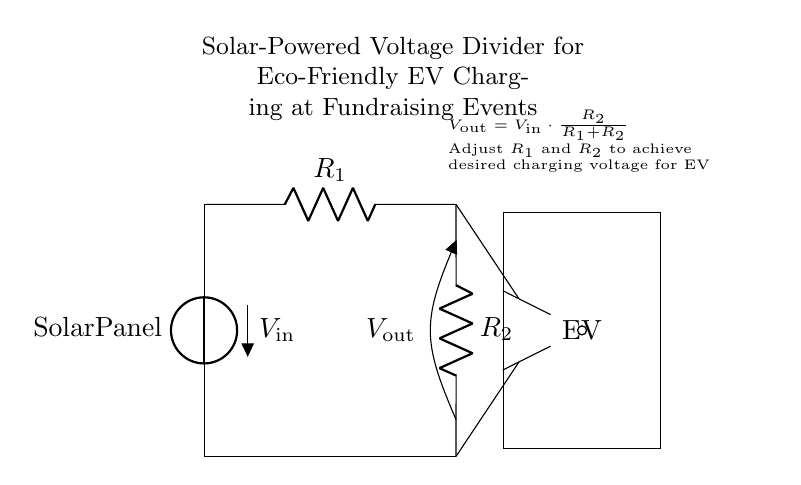What is the input voltage source in the circuit? The input voltage source is labeled as the solar panel, which provides the initial voltage for the voltage divider.
Answer: Solar Panel What are the two resistors in the voltage divider? The two resistors are labeled as R1 and R2, which are crucial for determining the output voltage of the divider based on their values.
Answer: R1 and R2 What is the formula for the output voltage? The formula given in the circuit diagram relates the input voltage, R1, and R2 to the output voltage, showing how they are mathematically connected.
Answer: Vout = Vin * R2 / (R1 + R2) How does adjusting R1 or R2 affect the output voltage? Adjusting either R1 or R2 will change the ratio of R2 to the total resistance (R1 + R2), thereby affecting the output voltage according to the voltage divider formula.
Answer: Changes output voltage What is the purpose of the charging symbol labeled as "EV"? The charging symbol represents the electric vehicle, indicating that the output voltage from the voltage divider is intended to charge the EV's battery.
Answer: Charge EV battery How does this circuit align with eco-friendly initiatives? The circuit uses a solar panel as an energy source, which is renewable and minimizes environmental impact, aligning with eco-friendly values at fundraising events.
Answer: Solar-powered 